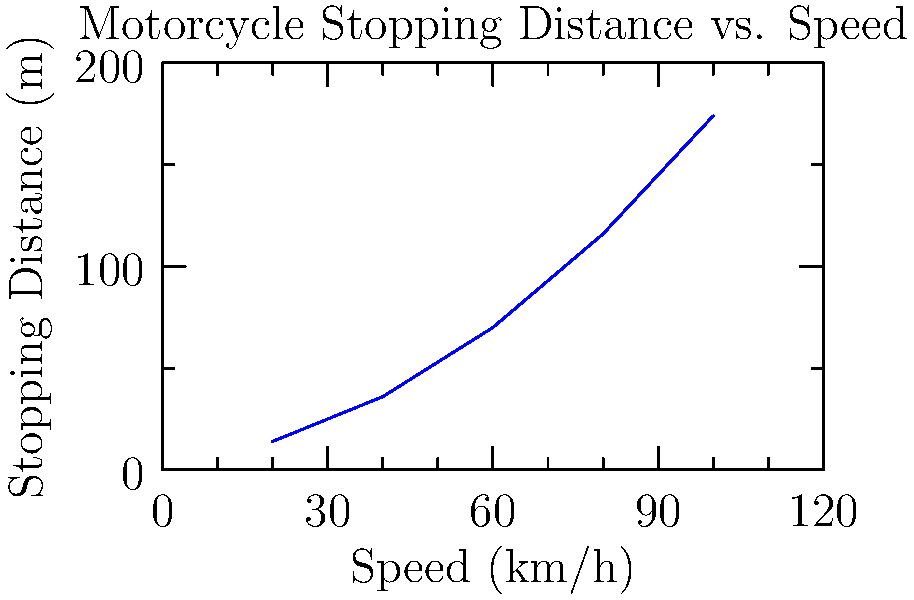Your husband is considering upgrading his motorcycle to a faster model. Using the graph, which shows the relationship between a motorcycle's speed and its stopping distance, calculate the increase in stopping distance if he were to increase his typical riding speed from 60 km/h to 80 km/h. How might this affect your concerns about his safety? To solve this problem, we need to follow these steps:

1. Identify the stopping distances for 60 km/h and 80 km/h from the graph:
   At 60 km/h: Stopping distance ≈ 70 m
   At 80 km/h: Stopping distance ≈ 116 m

2. Calculate the difference in stopping distances:
   $\text{Difference} = 116 \text{ m} - 70 \text{ m} = 46 \text{ m}$

3. Interpret the result:
   The stopping distance increases by 46 meters when the speed increases from 60 km/h to 80 km/h.

4. Safety implications:
   This significant increase in stopping distance (about 66% longer) could heighten safety concerns. It means that at the higher speed, your husband would need considerably more distance to bring the motorcycle to a complete stop in an emergency situation, potentially increasing the risk of accidents.
Answer: 46 meters increase in stopping distance 